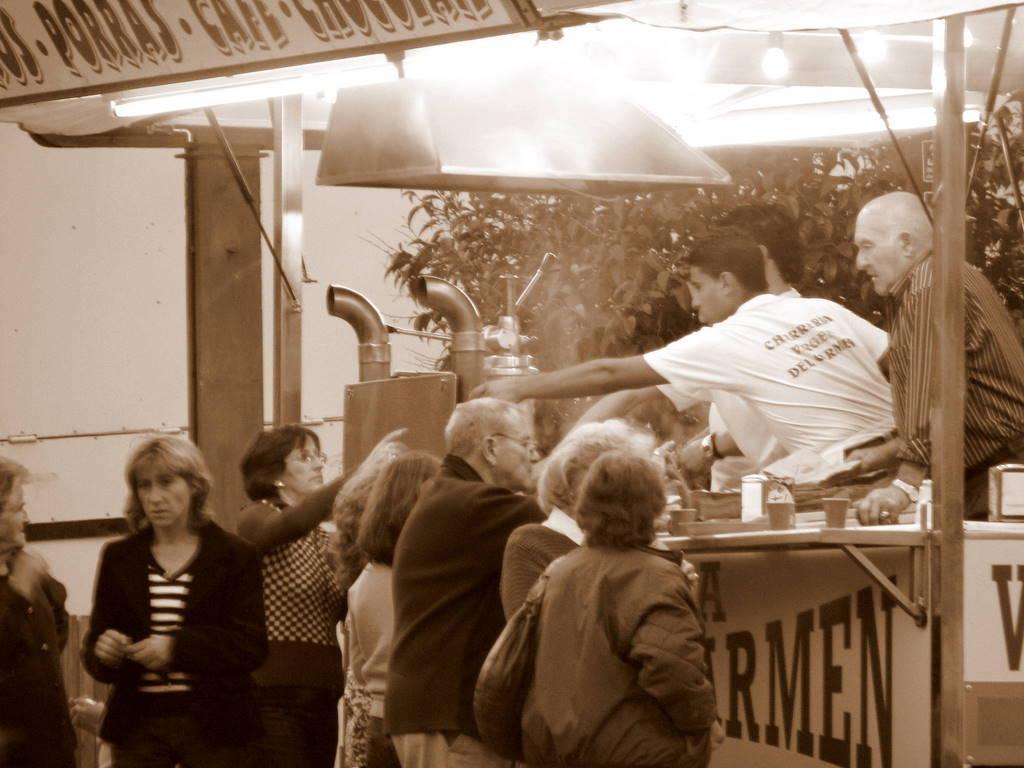Could you give a brief overview of what you see in this image? In the foreground of this image, on the bottom, there are persons standing near a stole in which there are three men standing. On the desk, there are few glasses. On the top, there is a board and lights. In the background, it seems like boilers, trees and the wall. 